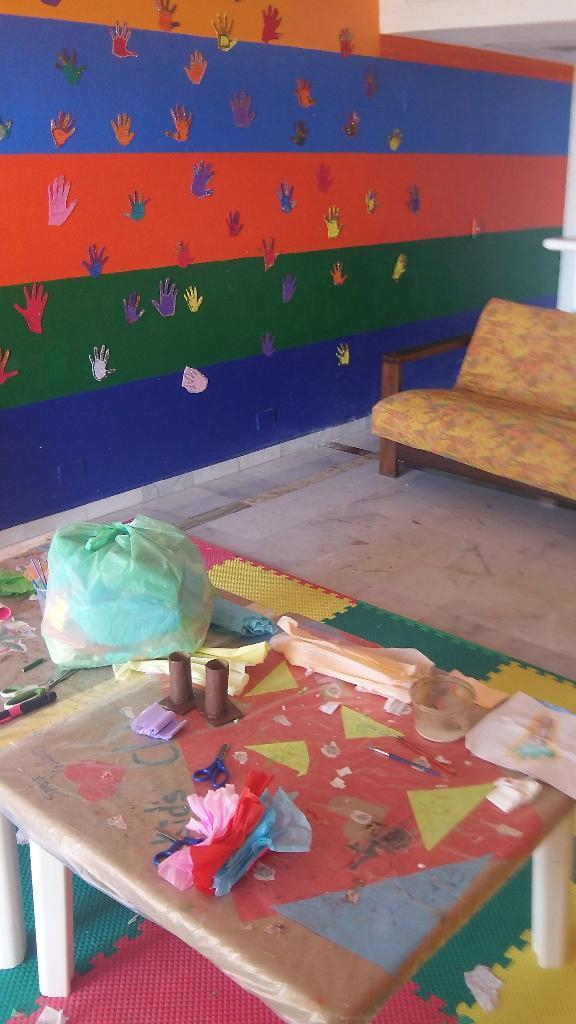Can you describe this image briefly? In this image I can see a couch and table. On a table there are paper,scissors,bowl,brushes and a plastic cover. At the back side there is a colorful wall. On the wall there are hand prints sticked on the wall. 